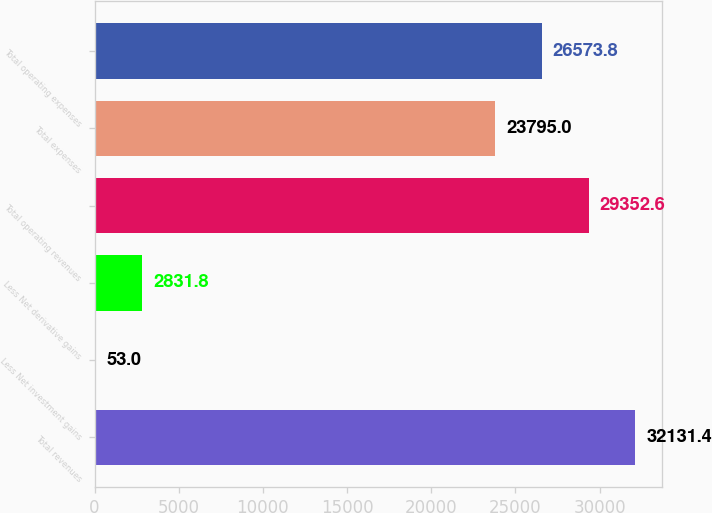<chart> <loc_0><loc_0><loc_500><loc_500><bar_chart><fcel>Total revenues<fcel>Less Net investment gains<fcel>Less Net derivative gains<fcel>Total operating revenues<fcel>Total expenses<fcel>Total operating expenses<nl><fcel>32131.4<fcel>53<fcel>2831.8<fcel>29352.6<fcel>23795<fcel>26573.8<nl></chart> 